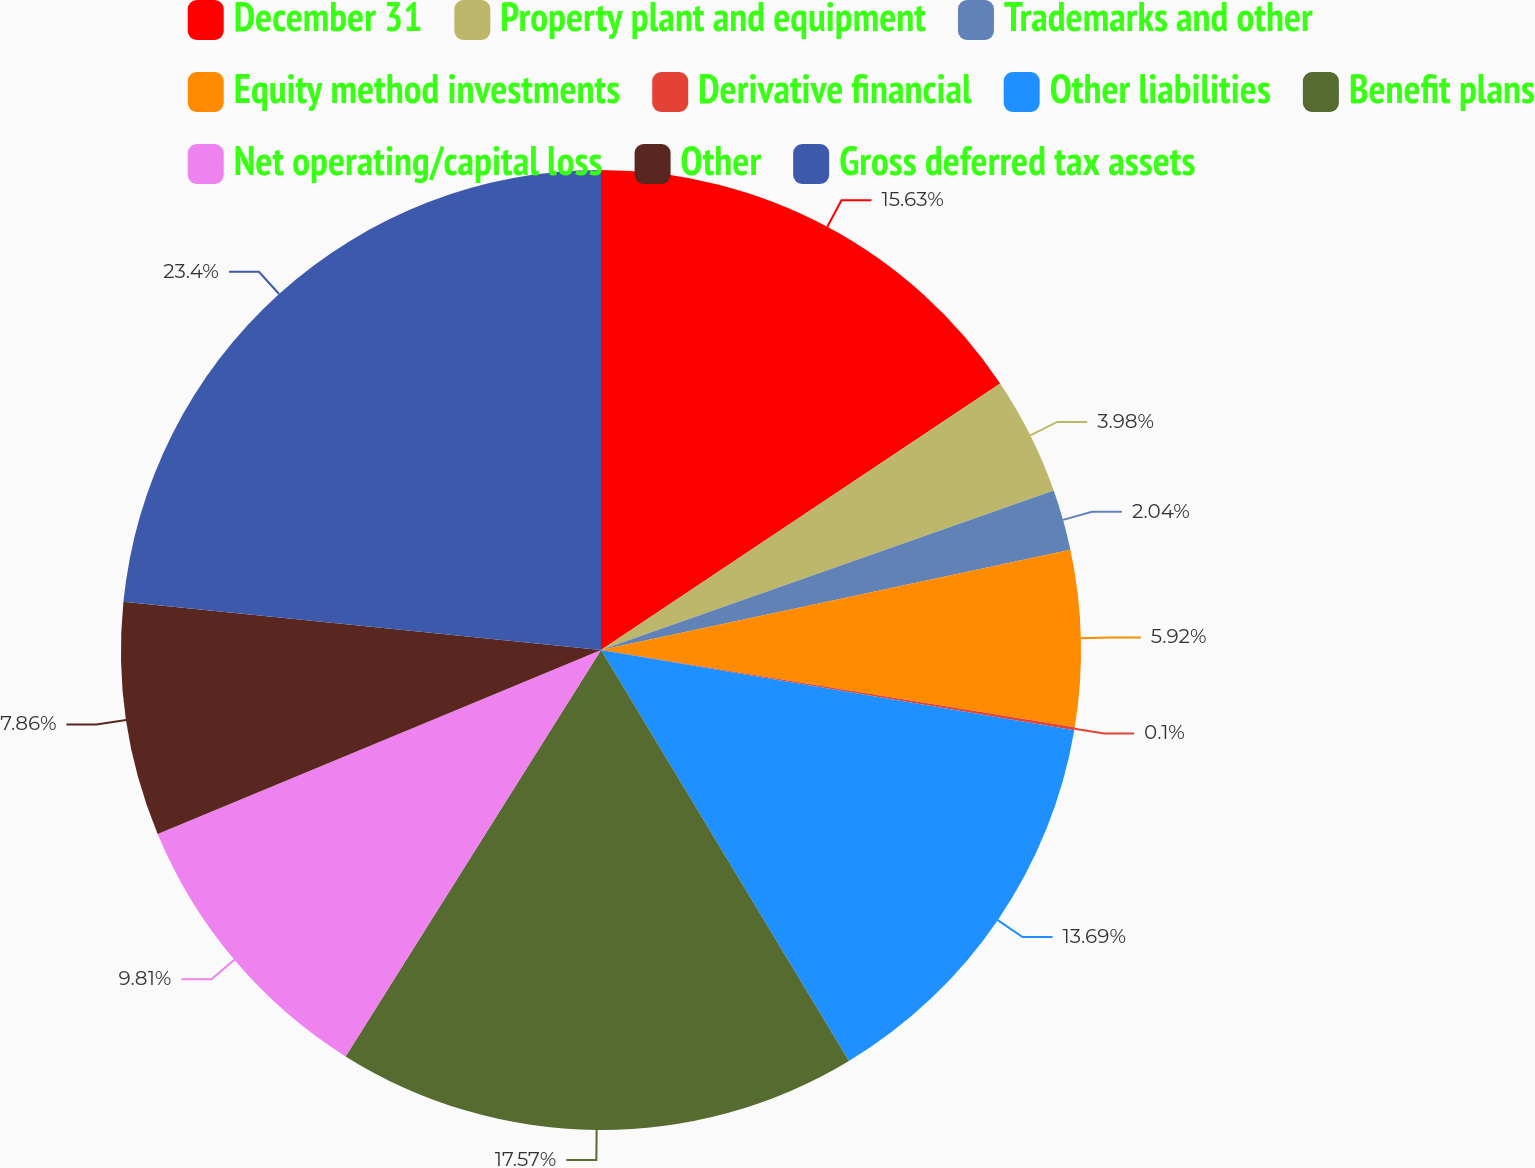Convert chart to OTSL. <chart><loc_0><loc_0><loc_500><loc_500><pie_chart><fcel>December 31<fcel>Property plant and equipment<fcel>Trademarks and other<fcel>Equity method investments<fcel>Derivative financial<fcel>Other liabilities<fcel>Benefit plans<fcel>Net operating/capital loss<fcel>Other<fcel>Gross deferred tax assets<nl><fcel>15.63%<fcel>3.98%<fcel>2.04%<fcel>5.92%<fcel>0.1%<fcel>13.69%<fcel>17.57%<fcel>9.81%<fcel>7.86%<fcel>23.4%<nl></chart> 